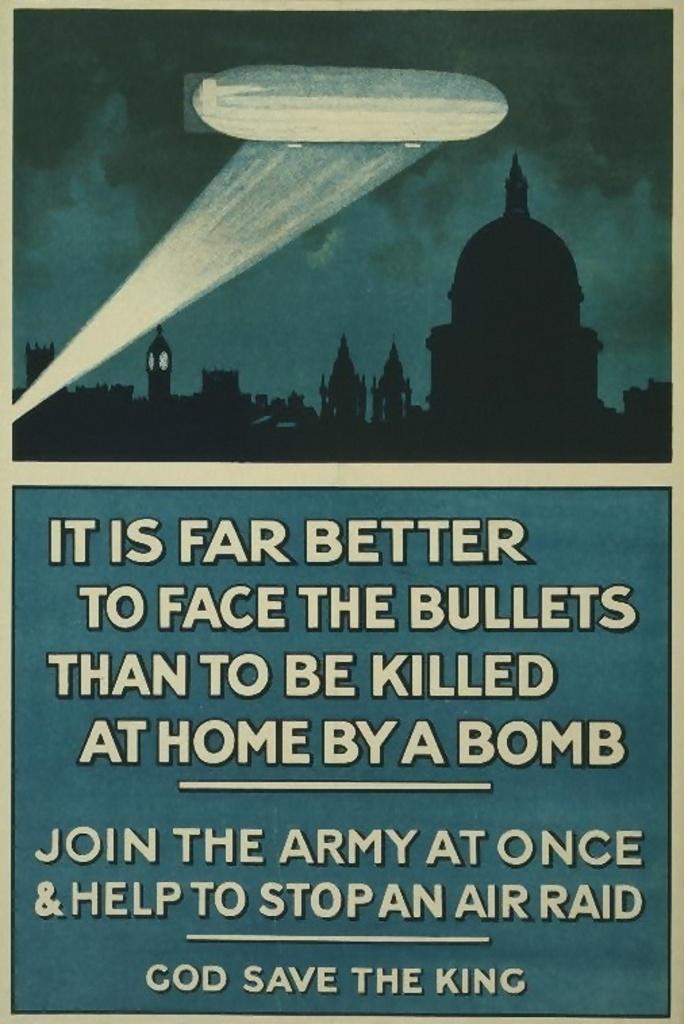Who should god save?
Offer a terse response. The king. Is god save the queen a british saying?
Make the answer very short. Unanswerable. 